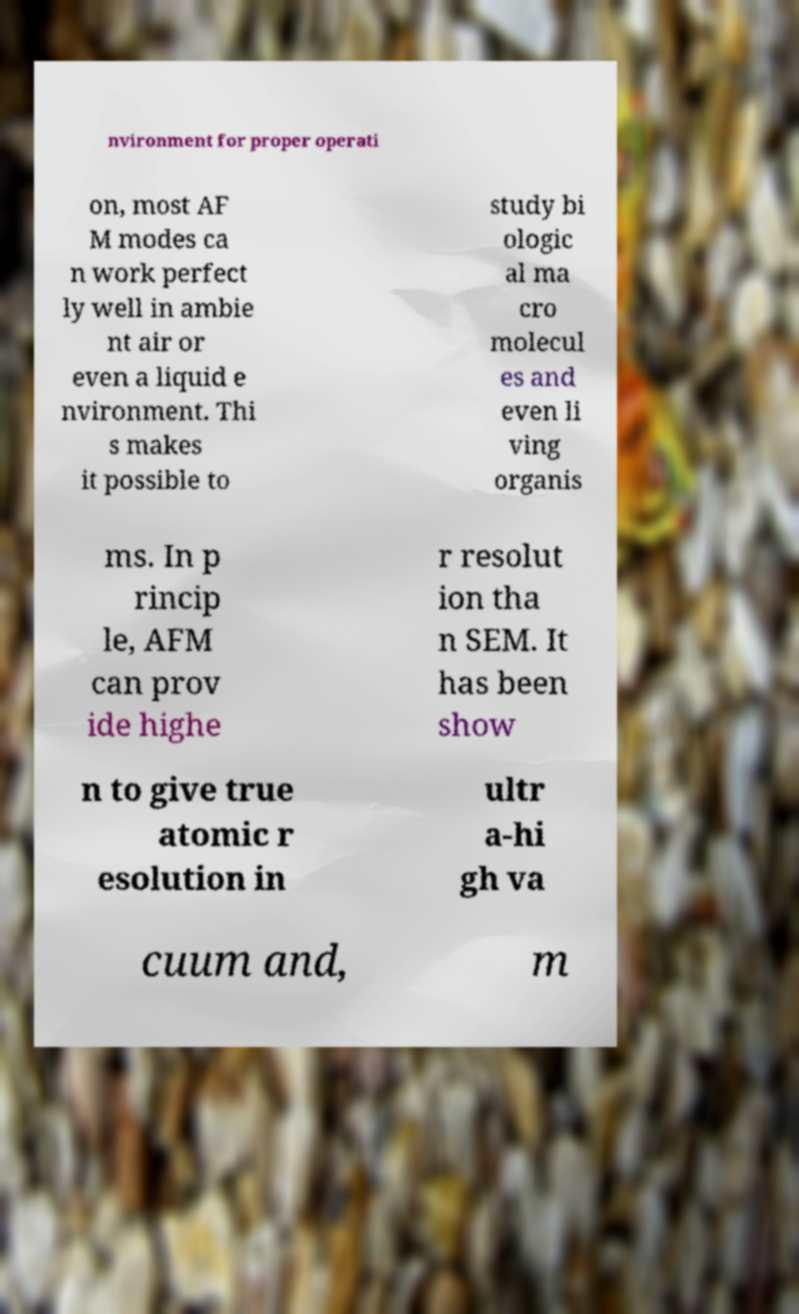Could you extract and type out the text from this image? nvironment for proper operati on, most AF M modes ca n work perfect ly well in ambie nt air or even a liquid e nvironment. Thi s makes it possible to study bi ologic al ma cro molecul es and even li ving organis ms. In p rincip le, AFM can prov ide highe r resolut ion tha n SEM. It has been show n to give true atomic r esolution in ultr a-hi gh va cuum and, m 